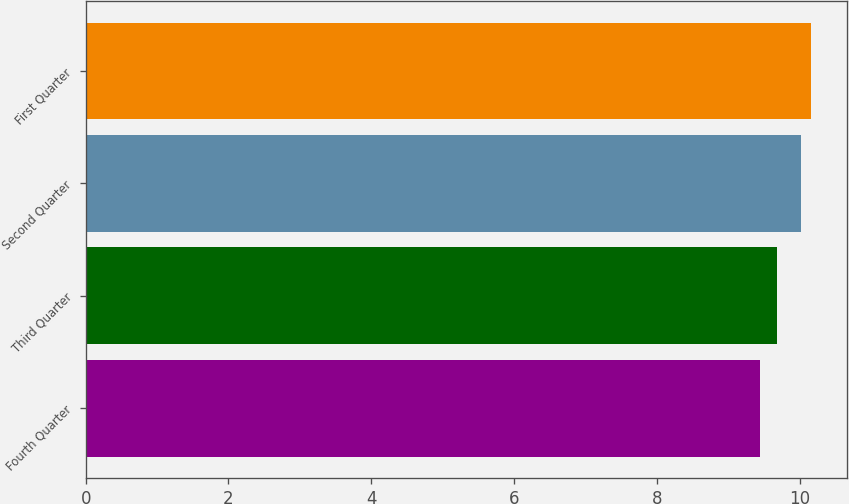Convert chart to OTSL. <chart><loc_0><loc_0><loc_500><loc_500><bar_chart><fcel>Fourth Quarter<fcel>Third Quarter<fcel>Second Quarter<fcel>First Quarter<nl><fcel>9.45<fcel>9.68<fcel>10.02<fcel>10.16<nl></chart> 